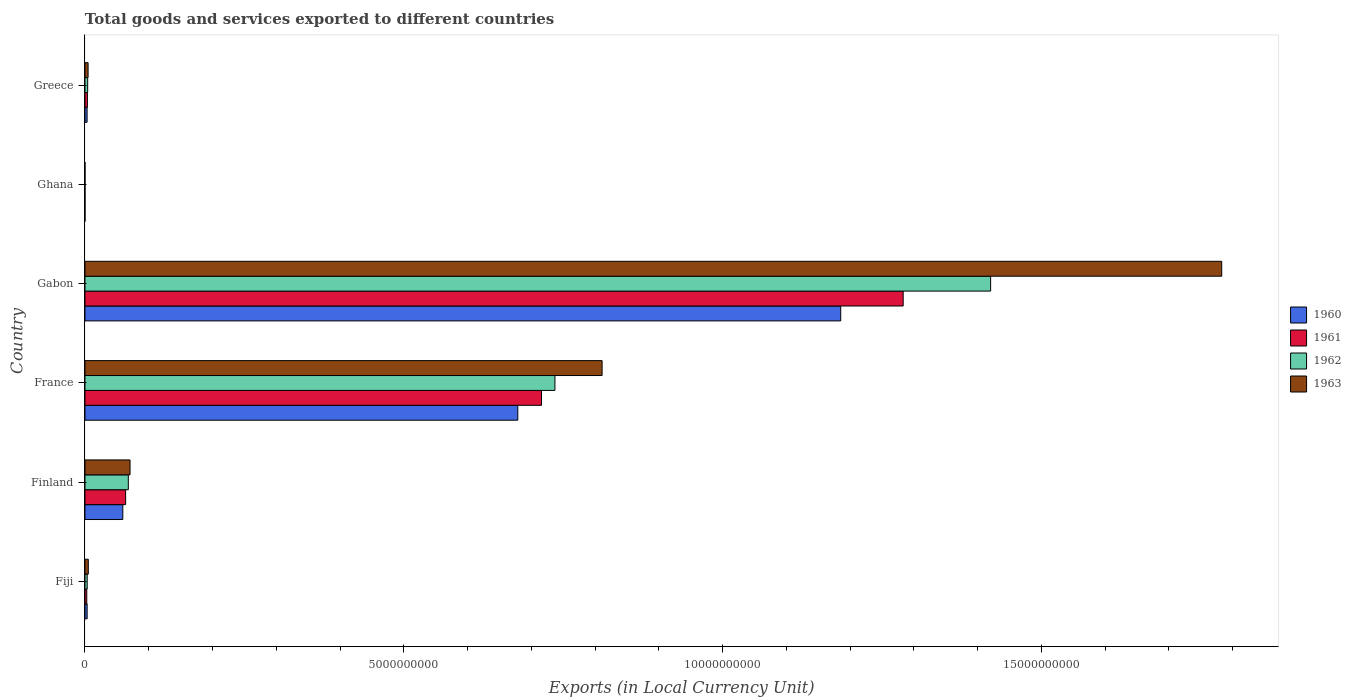How many different coloured bars are there?
Your response must be concise. 4. Are the number of bars on each tick of the Y-axis equal?
Make the answer very short. Yes. How many bars are there on the 5th tick from the top?
Ensure brevity in your answer.  4. How many bars are there on the 2nd tick from the bottom?
Keep it short and to the point. 4. What is the label of the 4th group of bars from the top?
Make the answer very short. France. What is the Amount of goods and services exports in 1962 in France?
Offer a very short reply. 7.37e+09. Across all countries, what is the maximum Amount of goods and services exports in 1961?
Make the answer very short. 1.28e+1. Across all countries, what is the minimum Amount of goods and services exports in 1960?
Your answer should be compact. 2.45e+04. In which country was the Amount of goods and services exports in 1961 maximum?
Offer a terse response. Gabon. What is the total Amount of goods and services exports in 1962 in the graph?
Your response must be concise. 2.23e+1. What is the difference between the Amount of goods and services exports in 1960 in France and that in Gabon?
Your answer should be compact. -5.06e+09. What is the difference between the Amount of goods and services exports in 1961 in France and the Amount of goods and services exports in 1962 in Fiji?
Your answer should be compact. 7.13e+09. What is the average Amount of goods and services exports in 1963 per country?
Offer a very short reply. 4.46e+09. What is the difference between the Amount of goods and services exports in 1961 and Amount of goods and services exports in 1962 in Fiji?
Provide a short and direct response. -6.30e+06. In how many countries, is the Amount of goods and services exports in 1960 greater than 8000000000 LCU?
Give a very brief answer. 1. What is the ratio of the Amount of goods and services exports in 1961 in Fiji to that in Ghana?
Offer a very short reply. 1172.84. Is the Amount of goods and services exports in 1963 in Finland less than that in Greece?
Offer a terse response. No. What is the difference between the highest and the second highest Amount of goods and services exports in 1962?
Offer a very short reply. 6.83e+09. What is the difference between the highest and the lowest Amount of goods and services exports in 1960?
Your answer should be compact. 1.19e+1. Is the sum of the Amount of goods and services exports in 1962 in Fiji and Ghana greater than the maximum Amount of goods and services exports in 1960 across all countries?
Offer a terse response. No. Is it the case that in every country, the sum of the Amount of goods and services exports in 1960 and Amount of goods and services exports in 1961 is greater than the sum of Amount of goods and services exports in 1963 and Amount of goods and services exports in 1962?
Your answer should be compact. No. What does the 1st bar from the top in France represents?
Ensure brevity in your answer.  1963. How many countries are there in the graph?
Offer a terse response. 6. How many legend labels are there?
Ensure brevity in your answer.  4. What is the title of the graph?
Provide a succinct answer. Total goods and services exported to different countries. Does "1983" appear as one of the legend labels in the graph?
Offer a very short reply. No. What is the label or title of the X-axis?
Ensure brevity in your answer.  Exports (in Local Currency Unit). What is the label or title of the Y-axis?
Offer a terse response. Country. What is the Exports (in Local Currency Unit) of 1960 in Fiji?
Provide a short and direct response. 3.40e+07. What is the Exports (in Local Currency Unit) of 1961 in Fiji?
Give a very brief answer. 2.85e+07. What is the Exports (in Local Currency Unit) in 1962 in Fiji?
Your answer should be very brief. 3.48e+07. What is the Exports (in Local Currency Unit) in 1963 in Fiji?
Your answer should be very brief. 5.25e+07. What is the Exports (in Local Currency Unit) in 1960 in Finland?
Provide a short and direct response. 5.94e+08. What is the Exports (in Local Currency Unit) in 1961 in Finland?
Your answer should be very brief. 6.38e+08. What is the Exports (in Local Currency Unit) of 1962 in Finland?
Your answer should be compact. 6.80e+08. What is the Exports (in Local Currency Unit) in 1963 in Finland?
Offer a terse response. 7.07e+08. What is the Exports (in Local Currency Unit) in 1960 in France?
Your answer should be very brief. 6.79e+09. What is the Exports (in Local Currency Unit) in 1961 in France?
Keep it short and to the point. 7.16e+09. What is the Exports (in Local Currency Unit) in 1962 in France?
Keep it short and to the point. 7.37e+09. What is the Exports (in Local Currency Unit) of 1963 in France?
Offer a terse response. 8.11e+09. What is the Exports (in Local Currency Unit) of 1960 in Gabon?
Your response must be concise. 1.19e+1. What is the Exports (in Local Currency Unit) in 1961 in Gabon?
Ensure brevity in your answer.  1.28e+1. What is the Exports (in Local Currency Unit) in 1962 in Gabon?
Your answer should be compact. 1.42e+1. What is the Exports (in Local Currency Unit) of 1963 in Gabon?
Offer a very short reply. 1.78e+1. What is the Exports (in Local Currency Unit) of 1960 in Ghana?
Give a very brief answer. 2.45e+04. What is the Exports (in Local Currency Unit) in 1961 in Ghana?
Give a very brief answer. 2.43e+04. What is the Exports (in Local Currency Unit) of 1962 in Ghana?
Offer a very short reply. 2.39e+04. What is the Exports (in Local Currency Unit) in 1963 in Ghana?
Provide a succinct answer. 2.33e+04. What is the Exports (in Local Currency Unit) in 1960 in Greece?
Provide a succinct answer. 3.33e+07. What is the Exports (in Local Currency Unit) in 1961 in Greece?
Provide a short and direct response. 3.82e+07. What is the Exports (in Local Currency Unit) in 1962 in Greece?
Provide a short and direct response. 4.25e+07. What is the Exports (in Local Currency Unit) of 1963 in Greece?
Provide a short and direct response. 4.90e+07. Across all countries, what is the maximum Exports (in Local Currency Unit) in 1960?
Your response must be concise. 1.19e+1. Across all countries, what is the maximum Exports (in Local Currency Unit) in 1961?
Provide a short and direct response. 1.28e+1. Across all countries, what is the maximum Exports (in Local Currency Unit) in 1962?
Provide a short and direct response. 1.42e+1. Across all countries, what is the maximum Exports (in Local Currency Unit) of 1963?
Give a very brief answer. 1.78e+1. Across all countries, what is the minimum Exports (in Local Currency Unit) in 1960?
Make the answer very short. 2.45e+04. Across all countries, what is the minimum Exports (in Local Currency Unit) of 1961?
Offer a very short reply. 2.43e+04. Across all countries, what is the minimum Exports (in Local Currency Unit) of 1962?
Offer a very short reply. 2.39e+04. Across all countries, what is the minimum Exports (in Local Currency Unit) in 1963?
Your response must be concise. 2.33e+04. What is the total Exports (in Local Currency Unit) of 1960 in the graph?
Make the answer very short. 1.93e+1. What is the total Exports (in Local Currency Unit) in 1961 in the graph?
Make the answer very short. 2.07e+1. What is the total Exports (in Local Currency Unit) of 1962 in the graph?
Make the answer very short. 2.23e+1. What is the total Exports (in Local Currency Unit) in 1963 in the graph?
Your answer should be very brief. 2.67e+1. What is the difference between the Exports (in Local Currency Unit) of 1960 in Fiji and that in Finland?
Make the answer very short. -5.60e+08. What is the difference between the Exports (in Local Currency Unit) of 1961 in Fiji and that in Finland?
Your response must be concise. -6.09e+08. What is the difference between the Exports (in Local Currency Unit) of 1962 in Fiji and that in Finland?
Offer a terse response. -6.45e+08. What is the difference between the Exports (in Local Currency Unit) in 1963 in Fiji and that in Finland?
Your response must be concise. -6.54e+08. What is the difference between the Exports (in Local Currency Unit) of 1960 in Fiji and that in France?
Your response must be concise. -6.75e+09. What is the difference between the Exports (in Local Currency Unit) in 1961 in Fiji and that in France?
Your response must be concise. -7.13e+09. What is the difference between the Exports (in Local Currency Unit) of 1962 in Fiji and that in France?
Give a very brief answer. -7.34e+09. What is the difference between the Exports (in Local Currency Unit) in 1963 in Fiji and that in France?
Your answer should be very brief. -8.06e+09. What is the difference between the Exports (in Local Currency Unit) in 1960 in Fiji and that in Gabon?
Give a very brief answer. -1.18e+1. What is the difference between the Exports (in Local Currency Unit) in 1961 in Fiji and that in Gabon?
Keep it short and to the point. -1.28e+1. What is the difference between the Exports (in Local Currency Unit) in 1962 in Fiji and that in Gabon?
Your answer should be compact. -1.42e+1. What is the difference between the Exports (in Local Currency Unit) in 1963 in Fiji and that in Gabon?
Provide a short and direct response. -1.78e+1. What is the difference between the Exports (in Local Currency Unit) in 1960 in Fiji and that in Ghana?
Your answer should be compact. 3.40e+07. What is the difference between the Exports (in Local Currency Unit) in 1961 in Fiji and that in Ghana?
Your response must be concise. 2.85e+07. What is the difference between the Exports (in Local Currency Unit) in 1962 in Fiji and that in Ghana?
Offer a terse response. 3.48e+07. What is the difference between the Exports (in Local Currency Unit) of 1963 in Fiji and that in Ghana?
Your answer should be compact. 5.25e+07. What is the difference between the Exports (in Local Currency Unit) in 1960 in Fiji and that in Greece?
Your answer should be compact. 6.78e+05. What is the difference between the Exports (in Local Currency Unit) in 1961 in Fiji and that in Greece?
Your response must be concise. -9.72e+06. What is the difference between the Exports (in Local Currency Unit) in 1962 in Fiji and that in Greece?
Your answer should be very brief. -7.71e+06. What is the difference between the Exports (in Local Currency Unit) in 1963 in Fiji and that in Greece?
Keep it short and to the point. 3.52e+06. What is the difference between the Exports (in Local Currency Unit) in 1960 in Finland and that in France?
Offer a terse response. -6.19e+09. What is the difference between the Exports (in Local Currency Unit) in 1961 in Finland and that in France?
Offer a very short reply. -6.52e+09. What is the difference between the Exports (in Local Currency Unit) of 1962 in Finland and that in France?
Provide a succinct answer. -6.69e+09. What is the difference between the Exports (in Local Currency Unit) in 1963 in Finland and that in France?
Ensure brevity in your answer.  -7.40e+09. What is the difference between the Exports (in Local Currency Unit) of 1960 in Finland and that in Gabon?
Provide a short and direct response. -1.13e+1. What is the difference between the Exports (in Local Currency Unit) of 1961 in Finland and that in Gabon?
Your answer should be very brief. -1.22e+1. What is the difference between the Exports (in Local Currency Unit) in 1962 in Finland and that in Gabon?
Give a very brief answer. -1.35e+1. What is the difference between the Exports (in Local Currency Unit) in 1963 in Finland and that in Gabon?
Provide a short and direct response. -1.71e+1. What is the difference between the Exports (in Local Currency Unit) of 1960 in Finland and that in Ghana?
Ensure brevity in your answer.  5.94e+08. What is the difference between the Exports (in Local Currency Unit) of 1961 in Finland and that in Ghana?
Your answer should be compact. 6.38e+08. What is the difference between the Exports (in Local Currency Unit) of 1962 in Finland and that in Ghana?
Your answer should be very brief. 6.80e+08. What is the difference between the Exports (in Local Currency Unit) in 1963 in Finland and that in Ghana?
Make the answer very short. 7.07e+08. What is the difference between the Exports (in Local Currency Unit) in 1960 in Finland and that in Greece?
Offer a terse response. 5.60e+08. What is the difference between the Exports (in Local Currency Unit) in 1961 in Finland and that in Greece?
Offer a terse response. 5.99e+08. What is the difference between the Exports (in Local Currency Unit) in 1962 in Finland and that in Greece?
Your answer should be very brief. 6.37e+08. What is the difference between the Exports (in Local Currency Unit) of 1963 in Finland and that in Greece?
Make the answer very short. 6.58e+08. What is the difference between the Exports (in Local Currency Unit) of 1960 in France and that in Gabon?
Offer a very short reply. -5.06e+09. What is the difference between the Exports (in Local Currency Unit) of 1961 in France and that in Gabon?
Your answer should be very brief. -5.67e+09. What is the difference between the Exports (in Local Currency Unit) in 1962 in France and that in Gabon?
Your answer should be very brief. -6.83e+09. What is the difference between the Exports (in Local Currency Unit) in 1963 in France and that in Gabon?
Your answer should be very brief. -9.72e+09. What is the difference between the Exports (in Local Currency Unit) in 1960 in France and that in Ghana?
Give a very brief answer. 6.79e+09. What is the difference between the Exports (in Local Currency Unit) in 1961 in France and that in Ghana?
Your answer should be very brief. 7.16e+09. What is the difference between the Exports (in Local Currency Unit) in 1962 in France and that in Ghana?
Ensure brevity in your answer.  7.37e+09. What is the difference between the Exports (in Local Currency Unit) in 1963 in France and that in Ghana?
Provide a short and direct response. 8.11e+09. What is the difference between the Exports (in Local Currency Unit) in 1960 in France and that in Greece?
Ensure brevity in your answer.  6.76e+09. What is the difference between the Exports (in Local Currency Unit) in 1961 in France and that in Greece?
Your answer should be very brief. 7.12e+09. What is the difference between the Exports (in Local Currency Unit) of 1962 in France and that in Greece?
Your answer should be very brief. 7.33e+09. What is the difference between the Exports (in Local Currency Unit) in 1963 in France and that in Greece?
Provide a short and direct response. 8.06e+09. What is the difference between the Exports (in Local Currency Unit) of 1960 in Gabon and that in Ghana?
Keep it short and to the point. 1.19e+1. What is the difference between the Exports (in Local Currency Unit) in 1961 in Gabon and that in Ghana?
Give a very brief answer. 1.28e+1. What is the difference between the Exports (in Local Currency Unit) in 1962 in Gabon and that in Ghana?
Ensure brevity in your answer.  1.42e+1. What is the difference between the Exports (in Local Currency Unit) in 1963 in Gabon and that in Ghana?
Provide a short and direct response. 1.78e+1. What is the difference between the Exports (in Local Currency Unit) in 1960 in Gabon and that in Greece?
Provide a succinct answer. 1.18e+1. What is the difference between the Exports (in Local Currency Unit) in 1961 in Gabon and that in Greece?
Provide a short and direct response. 1.28e+1. What is the difference between the Exports (in Local Currency Unit) of 1962 in Gabon and that in Greece?
Your response must be concise. 1.42e+1. What is the difference between the Exports (in Local Currency Unit) in 1963 in Gabon and that in Greece?
Provide a succinct answer. 1.78e+1. What is the difference between the Exports (in Local Currency Unit) in 1960 in Ghana and that in Greece?
Make the answer very short. -3.33e+07. What is the difference between the Exports (in Local Currency Unit) in 1961 in Ghana and that in Greece?
Keep it short and to the point. -3.82e+07. What is the difference between the Exports (in Local Currency Unit) of 1962 in Ghana and that in Greece?
Provide a succinct answer. -4.25e+07. What is the difference between the Exports (in Local Currency Unit) of 1963 in Ghana and that in Greece?
Make the answer very short. -4.90e+07. What is the difference between the Exports (in Local Currency Unit) of 1960 in Fiji and the Exports (in Local Currency Unit) of 1961 in Finland?
Your answer should be very brief. -6.04e+08. What is the difference between the Exports (in Local Currency Unit) in 1960 in Fiji and the Exports (in Local Currency Unit) in 1962 in Finland?
Your response must be concise. -6.46e+08. What is the difference between the Exports (in Local Currency Unit) in 1960 in Fiji and the Exports (in Local Currency Unit) in 1963 in Finland?
Offer a very short reply. -6.73e+08. What is the difference between the Exports (in Local Currency Unit) in 1961 in Fiji and the Exports (in Local Currency Unit) in 1962 in Finland?
Make the answer very short. -6.51e+08. What is the difference between the Exports (in Local Currency Unit) of 1961 in Fiji and the Exports (in Local Currency Unit) of 1963 in Finland?
Provide a short and direct response. -6.78e+08. What is the difference between the Exports (in Local Currency Unit) of 1962 in Fiji and the Exports (in Local Currency Unit) of 1963 in Finland?
Make the answer very short. -6.72e+08. What is the difference between the Exports (in Local Currency Unit) in 1960 in Fiji and the Exports (in Local Currency Unit) in 1961 in France?
Ensure brevity in your answer.  -7.13e+09. What is the difference between the Exports (in Local Currency Unit) in 1960 in Fiji and the Exports (in Local Currency Unit) in 1962 in France?
Give a very brief answer. -7.34e+09. What is the difference between the Exports (in Local Currency Unit) of 1960 in Fiji and the Exports (in Local Currency Unit) of 1963 in France?
Offer a very short reply. -8.08e+09. What is the difference between the Exports (in Local Currency Unit) in 1961 in Fiji and the Exports (in Local Currency Unit) in 1962 in France?
Your answer should be very brief. -7.34e+09. What is the difference between the Exports (in Local Currency Unit) of 1961 in Fiji and the Exports (in Local Currency Unit) of 1963 in France?
Offer a terse response. -8.08e+09. What is the difference between the Exports (in Local Currency Unit) in 1962 in Fiji and the Exports (in Local Currency Unit) in 1963 in France?
Your answer should be compact. -8.08e+09. What is the difference between the Exports (in Local Currency Unit) in 1960 in Fiji and the Exports (in Local Currency Unit) in 1961 in Gabon?
Your response must be concise. -1.28e+1. What is the difference between the Exports (in Local Currency Unit) in 1960 in Fiji and the Exports (in Local Currency Unit) in 1962 in Gabon?
Your answer should be very brief. -1.42e+1. What is the difference between the Exports (in Local Currency Unit) in 1960 in Fiji and the Exports (in Local Currency Unit) in 1963 in Gabon?
Provide a short and direct response. -1.78e+1. What is the difference between the Exports (in Local Currency Unit) of 1961 in Fiji and the Exports (in Local Currency Unit) of 1962 in Gabon?
Make the answer very short. -1.42e+1. What is the difference between the Exports (in Local Currency Unit) in 1961 in Fiji and the Exports (in Local Currency Unit) in 1963 in Gabon?
Your answer should be compact. -1.78e+1. What is the difference between the Exports (in Local Currency Unit) of 1962 in Fiji and the Exports (in Local Currency Unit) of 1963 in Gabon?
Your answer should be compact. -1.78e+1. What is the difference between the Exports (in Local Currency Unit) of 1960 in Fiji and the Exports (in Local Currency Unit) of 1961 in Ghana?
Give a very brief answer. 3.40e+07. What is the difference between the Exports (in Local Currency Unit) in 1960 in Fiji and the Exports (in Local Currency Unit) in 1962 in Ghana?
Your answer should be very brief. 3.40e+07. What is the difference between the Exports (in Local Currency Unit) in 1960 in Fiji and the Exports (in Local Currency Unit) in 1963 in Ghana?
Provide a succinct answer. 3.40e+07. What is the difference between the Exports (in Local Currency Unit) in 1961 in Fiji and the Exports (in Local Currency Unit) in 1962 in Ghana?
Your answer should be compact. 2.85e+07. What is the difference between the Exports (in Local Currency Unit) of 1961 in Fiji and the Exports (in Local Currency Unit) of 1963 in Ghana?
Give a very brief answer. 2.85e+07. What is the difference between the Exports (in Local Currency Unit) of 1962 in Fiji and the Exports (in Local Currency Unit) of 1963 in Ghana?
Give a very brief answer. 3.48e+07. What is the difference between the Exports (in Local Currency Unit) in 1960 in Fiji and the Exports (in Local Currency Unit) in 1961 in Greece?
Keep it short and to the point. -4.22e+06. What is the difference between the Exports (in Local Currency Unit) in 1960 in Fiji and the Exports (in Local Currency Unit) in 1962 in Greece?
Offer a terse response. -8.51e+06. What is the difference between the Exports (in Local Currency Unit) of 1960 in Fiji and the Exports (in Local Currency Unit) of 1963 in Greece?
Offer a terse response. -1.50e+07. What is the difference between the Exports (in Local Currency Unit) of 1961 in Fiji and the Exports (in Local Currency Unit) of 1962 in Greece?
Make the answer very short. -1.40e+07. What is the difference between the Exports (in Local Currency Unit) of 1961 in Fiji and the Exports (in Local Currency Unit) of 1963 in Greece?
Make the answer very short. -2.05e+07. What is the difference between the Exports (in Local Currency Unit) in 1962 in Fiji and the Exports (in Local Currency Unit) in 1963 in Greece?
Offer a very short reply. -1.42e+07. What is the difference between the Exports (in Local Currency Unit) in 1960 in Finland and the Exports (in Local Currency Unit) in 1961 in France?
Give a very brief answer. -6.57e+09. What is the difference between the Exports (in Local Currency Unit) of 1960 in Finland and the Exports (in Local Currency Unit) of 1962 in France?
Your response must be concise. -6.78e+09. What is the difference between the Exports (in Local Currency Unit) in 1960 in Finland and the Exports (in Local Currency Unit) in 1963 in France?
Provide a succinct answer. -7.52e+09. What is the difference between the Exports (in Local Currency Unit) in 1961 in Finland and the Exports (in Local Currency Unit) in 1962 in France?
Make the answer very short. -6.73e+09. What is the difference between the Exports (in Local Currency Unit) of 1961 in Finland and the Exports (in Local Currency Unit) of 1963 in France?
Provide a succinct answer. -7.47e+09. What is the difference between the Exports (in Local Currency Unit) in 1962 in Finland and the Exports (in Local Currency Unit) in 1963 in France?
Offer a terse response. -7.43e+09. What is the difference between the Exports (in Local Currency Unit) in 1960 in Finland and the Exports (in Local Currency Unit) in 1961 in Gabon?
Provide a succinct answer. -1.22e+1. What is the difference between the Exports (in Local Currency Unit) of 1960 in Finland and the Exports (in Local Currency Unit) of 1962 in Gabon?
Your response must be concise. -1.36e+1. What is the difference between the Exports (in Local Currency Unit) in 1960 in Finland and the Exports (in Local Currency Unit) in 1963 in Gabon?
Provide a succinct answer. -1.72e+1. What is the difference between the Exports (in Local Currency Unit) in 1961 in Finland and the Exports (in Local Currency Unit) in 1962 in Gabon?
Your answer should be compact. -1.36e+1. What is the difference between the Exports (in Local Currency Unit) of 1961 in Finland and the Exports (in Local Currency Unit) of 1963 in Gabon?
Your answer should be very brief. -1.72e+1. What is the difference between the Exports (in Local Currency Unit) of 1962 in Finland and the Exports (in Local Currency Unit) of 1963 in Gabon?
Your answer should be compact. -1.71e+1. What is the difference between the Exports (in Local Currency Unit) in 1960 in Finland and the Exports (in Local Currency Unit) in 1961 in Ghana?
Ensure brevity in your answer.  5.94e+08. What is the difference between the Exports (in Local Currency Unit) of 1960 in Finland and the Exports (in Local Currency Unit) of 1962 in Ghana?
Make the answer very short. 5.94e+08. What is the difference between the Exports (in Local Currency Unit) of 1960 in Finland and the Exports (in Local Currency Unit) of 1963 in Ghana?
Your response must be concise. 5.94e+08. What is the difference between the Exports (in Local Currency Unit) in 1961 in Finland and the Exports (in Local Currency Unit) in 1962 in Ghana?
Your response must be concise. 6.38e+08. What is the difference between the Exports (in Local Currency Unit) of 1961 in Finland and the Exports (in Local Currency Unit) of 1963 in Ghana?
Offer a very short reply. 6.38e+08. What is the difference between the Exports (in Local Currency Unit) of 1962 in Finland and the Exports (in Local Currency Unit) of 1963 in Ghana?
Your answer should be compact. 6.80e+08. What is the difference between the Exports (in Local Currency Unit) of 1960 in Finland and the Exports (in Local Currency Unit) of 1961 in Greece?
Provide a succinct answer. 5.55e+08. What is the difference between the Exports (in Local Currency Unit) of 1960 in Finland and the Exports (in Local Currency Unit) of 1962 in Greece?
Your answer should be compact. 5.51e+08. What is the difference between the Exports (in Local Currency Unit) in 1960 in Finland and the Exports (in Local Currency Unit) in 1963 in Greece?
Offer a very short reply. 5.45e+08. What is the difference between the Exports (in Local Currency Unit) of 1961 in Finland and the Exports (in Local Currency Unit) of 1962 in Greece?
Your answer should be very brief. 5.95e+08. What is the difference between the Exports (in Local Currency Unit) of 1961 in Finland and the Exports (in Local Currency Unit) of 1963 in Greece?
Keep it short and to the point. 5.89e+08. What is the difference between the Exports (in Local Currency Unit) in 1962 in Finland and the Exports (in Local Currency Unit) in 1963 in Greece?
Make the answer very short. 6.31e+08. What is the difference between the Exports (in Local Currency Unit) of 1960 in France and the Exports (in Local Currency Unit) of 1961 in Gabon?
Offer a very short reply. -6.04e+09. What is the difference between the Exports (in Local Currency Unit) of 1960 in France and the Exports (in Local Currency Unit) of 1962 in Gabon?
Provide a short and direct response. -7.42e+09. What is the difference between the Exports (in Local Currency Unit) in 1960 in France and the Exports (in Local Currency Unit) in 1963 in Gabon?
Your response must be concise. -1.10e+1. What is the difference between the Exports (in Local Currency Unit) in 1961 in France and the Exports (in Local Currency Unit) in 1962 in Gabon?
Offer a very short reply. -7.04e+09. What is the difference between the Exports (in Local Currency Unit) of 1961 in France and the Exports (in Local Currency Unit) of 1963 in Gabon?
Your response must be concise. -1.07e+1. What is the difference between the Exports (in Local Currency Unit) in 1962 in France and the Exports (in Local Currency Unit) in 1963 in Gabon?
Give a very brief answer. -1.05e+1. What is the difference between the Exports (in Local Currency Unit) of 1960 in France and the Exports (in Local Currency Unit) of 1961 in Ghana?
Give a very brief answer. 6.79e+09. What is the difference between the Exports (in Local Currency Unit) in 1960 in France and the Exports (in Local Currency Unit) in 1962 in Ghana?
Keep it short and to the point. 6.79e+09. What is the difference between the Exports (in Local Currency Unit) of 1960 in France and the Exports (in Local Currency Unit) of 1963 in Ghana?
Provide a succinct answer. 6.79e+09. What is the difference between the Exports (in Local Currency Unit) of 1961 in France and the Exports (in Local Currency Unit) of 1962 in Ghana?
Your response must be concise. 7.16e+09. What is the difference between the Exports (in Local Currency Unit) of 1961 in France and the Exports (in Local Currency Unit) of 1963 in Ghana?
Provide a short and direct response. 7.16e+09. What is the difference between the Exports (in Local Currency Unit) in 1962 in France and the Exports (in Local Currency Unit) in 1963 in Ghana?
Provide a succinct answer. 7.37e+09. What is the difference between the Exports (in Local Currency Unit) of 1960 in France and the Exports (in Local Currency Unit) of 1961 in Greece?
Offer a terse response. 6.75e+09. What is the difference between the Exports (in Local Currency Unit) of 1960 in France and the Exports (in Local Currency Unit) of 1962 in Greece?
Give a very brief answer. 6.75e+09. What is the difference between the Exports (in Local Currency Unit) of 1960 in France and the Exports (in Local Currency Unit) of 1963 in Greece?
Offer a very short reply. 6.74e+09. What is the difference between the Exports (in Local Currency Unit) of 1961 in France and the Exports (in Local Currency Unit) of 1962 in Greece?
Your response must be concise. 7.12e+09. What is the difference between the Exports (in Local Currency Unit) in 1961 in France and the Exports (in Local Currency Unit) in 1963 in Greece?
Give a very brief answer. 7.11e+09. What is the difference between the Exports (in Local Currency Unit) of 1962 in France and the Exports (in Local Currency Unit) of 1963 in Greece?
Offer a terse response. 7.32e+09. What is the difference between the Exports (in Local Currency Unit) of 1960 in Gabon and the Exports (in Local Currency Unit) of 1961 in Ghana?
Offer a very short reply. 1.19e+1. What is the difference between the Exports (in Local Currency Unit) in 1960 in Gabon and the Exports (in Local Currency Unit) in 1962 in Ghana?
Provide a short and direct response. 1.19e+1. What is the difference between the Exports (in Local Currency Unit) in 1960 in Gabon and the Exports (in Local Currency Unit) in 1963 in Ghana?
Offer a terse response. 1.19e+1. What is the difference between the Exports (in Local Currency Unit) in 1961 in Gabon and the Exports (in Local Currency Unit) in 1962 in Ghana?
Provide a short and direct response. 1.28e+1. What is the difference between the Exports (in Local Currency Unit) of 1961 in Gabon and the Exports (in Local Currency Unit) of 1963 in Ghana?
Make the answer very short. 1.28e+1. What is the difference between the Exports (in Local Currency Unit) of 1962 in Gabon and the Exports (in Local Currency Unit) of 1963 in Ghana?
Offer a very short reply. 1.42e+1. What is the difference between the Exports (in Local Currency Unit) in 1960 in Gabon and the Exports (in Local Currency Unit) in 1961 in Greece?
Offer a very short reply. 1.18e+1. What is the difference between the Exports (in Local Currency Unit) in 1960 in Gabon and the Exports (in Local Currency Unit) in 1962 in Greece?
Your response must be concise. 1.18e+1. What is the difference between the Exports (in Local Currency Unit) of 1960 in Gabon and the Exports (in Local Currency Unit) of 1963 in Greece?
Keep it short and to the point. 1.18e+1. What is the difference between the Exports (in Local Currency Unit) of 1961 in Gabon and the Exports (in Local Currency Unit) of 1962 in Greece?
Provide a succinct answer. 1.28e+1. What is the difference between the Exports (in Local Currency Unit) of 1961 in Gabon and the Exports (in Local Currency Unit) of 1963 in Greece?
Your answer should be very brief. 1.28e+1. What is the difference between the Exports (in Local Currency Unit) of 1962 in Gabon and the Exports (in Local Currency Unit) of 1963 in Greece?
Give a very brief answer. 1.42e+1. What is the difference between the Exports (in Local Currency Unit) of 1960 in Ghana and the Exports (in Local Currency Unit) of 1961 in Greece?
Your answer should be compact. -3.82e+07. What is the difference between the Exports (in Local Currency Unit) of 1960 in Ghana and the Exports (in Local Currency Unit) of 1962 in Greece?
Your response must be concise. -4.25e+07. What is the difference between the Exports (in Local Currency Unit) in 1960 in Ghana and the Exports (in Local Currency Unit) in 1963 in Greece?
Your answer should be compact. -4.90e+07. What is the difference between the Exports (in Local Currency Unit) of 1961 in Ghana and the Exports (in Local Currency Unit) of 1962 in Greece?
Give a very brief answer. -4.25e+07. What is the difference between the Exports (in Local Currency Unit) of 1961 in Ghana and the Exports (in Local Currency Unit) of 1963 in Greece?
Your response must be concise. -4.90e+07. What is the difference between the Exports (in Local Currency Unit) in 1962 in Ghana and the Exports (in Local Currency Unit) in 1963 in Greece?
Make the answer very short. -4.90e+07. What is the average Exports (in Local Currency Unit) in 1960 per country?
Your response must be concise. 3.22e+09. What is the average Exports (in Local Currency Unit) of 1961 per country?
Your response must be concise. 3.45e+09. What is the average Exports (in Local Currency Unit) of 1962 per country?
Offer a terse response. 3.72e+09. What is the average Exports (in Local Currency Unit) of 1963 per country?
Give a very brief answer. 4.46e+09. What is the difference between the Exports (in Local Currency Unit) of 1960 and Exports (in Local Currency Unit) of 1961 in Fiji?
Your response must be concise. 5.50e+06. What is the difference between the Exports (in Local Currency Unit) of 1960 and Exports (in Local Currency Unit) of 1962 in Fiji?
Provide a succinct answer. -8.00e+05. What is the difference between the Exports (in Local Currency Unit) in 1960 and Exports (in Local Currency Unit) in 1963 in Fiji?
Provide a short and direct response. -1.85e+07. What is the difference between the Exports (in Local Currency Unit) in 1961 and Exports (in Local Currency Unit) in 1962 in Fiji?
Make the answer very short. -6.30e+06. What is the difference between the Exports (in Local Currency Unit) in 1961 and Exports (in Local Currency Unit) in 1963 in Fiji?
Offer a terse response. -2.40e+07. What is the difference between the Exports (in Local Currency Unit) of 1962 and Exports (in Local Currency Unit) of 1963 in Fiji?
Your answer should be compact. -1.77e+07. What is the difference between the Exports (in Local Currency Unit) of 1960 and Exports (in Local Currency Unit) of 1961 in Finland?
Offer a terse response. -4.42e+07. What is the difference between the Exports (in Local Currency Unit) of 1960 and Exports (in Local Currency Unit) of 1962 in Finland?
Ensure brevity in your answer.  -8.63e+07. What is the difference between the Exports (in Local Currency Unit) of 1960 and Exports (in Local Currency Unit) of 1963 in Finland?
Your answer should be compact. -1.13e+08. What is the difference between the Exports (in Local Currency Unit) in 1961 and Exports (in Local Currency Unit) in 1962 in Finland?
Your answer should be very brief. -4.21e+07. What is the difference between the Exports (in Local Currency Unit) in 1961 and Exports (in Local Currency Unit) in 1963 in Finland?
Ensure brevity in your answer.  -6.91e+07. What is the difference between the Exports (in Local Currency Unit) of 1962 and Exports (in Local Currency Unit) of 1963 in Finland?
Offer a very short reply. -2.71e+07. What is the difference between the Exports (in Local Currency Unit) in 1960 and Exports (in Local Currency Unit) in 1961 in France?
Your response must be concise. -3.72e+08. What is the difference between the Exports (in Local Currency Unit) of 1960 and Exports (in Local Currency Unit) of 1962 in France?
Provide a succinct answer. -5.82e+08. What is the difference between the Exports (in Local Currency Unit) of 1960 and Exports (in Local Currency Unit) of 1963 in France?
Your answer should be compact. -1.32e+09. What is the difference between the Exports (in Local Currency Unit) in 1961 and Exports (in Local Currency Unit) in 1962 in France?
Keep it short and to the point. -2.11e+08. What is the difference between the Exports (in Local Currency Unit) of 1961 and Exports (in Local Currency Unit) of 1963 in France?
Your response must be concise. -9.50e+08. What is the difference between the Exports (in Local Currency Unit) in 1962 and Exports (in Local Currency Unit) in 1963 in France?
Offer a terse response. -7.39e+08. What is the difference between the Exports (in Local Currency Unit) of 1960 and Exports (in Local Currency Unit) of 1961 in Gabon?
Ensure brevity in your answer.  -9.80e+08. What is the difference between the Exports (in Local Currency Unit) of 1960 and Exports (in Local Currency Unit) of 1962 in Gabon?
Offer a very short reply. -2.35e+09. What is the difference between the Exports (in Local Currency Unit) in 1960 and Exports (in Local Currency Unit) in 1963 in Gabon?
Offer a terse response. -5.98e+09. What is the difference between the Exports (in Local Currency Unit) in 1961 and Exports (in Local Currency Unit) in 1962 in Gabon?
Give a very brief answer. -1.37e+09. What is the difference between the Exports (in Local Currency Unit) in 1961 and Exports (in Local Currency Unit) in 1963 in Gabon?
Your response must be concise. -5.00e+09. What is the difference between the Exports (in Local Currency Unit) of 1962 and Exports (in Local Currency Unit) of 1963 in Gabon?
Your answer should be very brief. -3.62e+09. What is the difference between the Exports (in Local Currency Unit) in 1960 and Exports (in Local Currency Unit) in 1961 in Ghana?
Your answer should be compact. 200. What is the difference between the Exports (in Local Currency Unit) of 1960 and Exports (in Local Currency Unit) of 1962 in Ghana?
Your response must be concise. 600. What is the difference between the Exports (in Local Currency Unit) of 1960 and Exports (in Local Currency Unit) of 1963 in Ghana?
Your answer should be very brief. 1200. What is the difference between the Exports (in Local Currency Unit) of 1962 and Exports (in Local Currency Unit) of 1963 in Ghana?
Make the answer very short. 600. What is the difference between the Exports (in Local Currency Unit) of 1960 and Exports (in Local Currency Unit) of 1961 in Greece?
Offer a terse response. -4.90e+06. What is the difference between the Exports (in Local Currency Unit) of 1960 and Exports (in Local Currency Unit) of 1962 in Greece?
Provide a short and direct response. -9.19e+06. What is the difference between the Exports (in Local Currency Unit) in 1960 and Exports (in Local Currency Unit) in 1963 in Greece?
Your response must be concise. -1.57e+07. What is the difference between the Exports (in Local Currency Unit) of 1961 and Exports (in Local Currency Unit) of 1962 in Greece?
Your response must be concise. -4.29e+06. What is the difference between the Exports (in Local Currency Unit) in 1961 and Exports (in Local Currency Unit) in 1963 in Greece?
Your response must be concise. -1.08e+07. What is the difference between the Exports (in Local Currency Unit) of 1962 and Exports (in Local Currency Unit) of 1963 in Greece?
Give a very brief answer. -6.47e+06. What is the ratio of the Exports (in Local Currency Unit) of 1960 in Fiji to that in Finland?
Ensure brevity in your answer.  0.06. What is the ratio of the Exports (in Local Currency Unit) in 1961 in Fiji to that in Finland?
Your answer should be compact. 0.04. What is the ratio of the Exports (in Local Currency Unit) of 1962 in Fiji to that in Finland?
Offer a terse response. 0.05. What is the ratio of the Exports (in Local Currency Unit) in 1963 in Fiji to that in Finland?
Keep it short and to the point. 0.07. What is the ratio of the Exports (in Local Currency Unit) in 1960 in Fiji to that in France?
Your response must be concise. 0.01. What is the ratio of the Exports (in Local Currency Unit) in 1961 in Fiji to that in France?
Make the answer very short. 0. What is the ratio of the Exports (in Local Currency Unit) in 1962 in Fiji to that in France?
Keep it short and to the point. 0. What is the ratio of the Exports (in Local Currency Unit) of 1963 in Fiji to that in France?
Your response must be concise. 0.01. What is the ratio of the Exports (in Local Currency Unit) of 1960 in Fiji to that in Gabon?
Make the answer very short. 0. What is the ratio of the Exports (in Local Currency Unit) of 1961 in Fiji to that in Gabon?
Ensure brevity in your answer.  0. What is the ratio of the Exports (in Local Currency Unit) of 1962 in Fiji to that in Gabon?
Keep it short and to the point. 0. What is the ratio of the Exports (in Local Currency Unit) of 1963 in Fiji to that in Gabon?
Offer a terse response. 0. What is the ratio of the Exports (in Local Currency Unit) of 1960 in Fiji to that in Ghana?
Keep it short and to the point. 1387.76. What is the ratio of the Exports (in Local Currency Unit) of 1961 in Fiji to that in Ghana?
Offer a very short reply. 1172.84. What is the ratio of the Exports (in Local Currency Unit) of 1962 in Fiji to that in Ghana?
Ensure brevity in your answer.  1456.07. What is the ratio of the Exports (in Local Currency Unit) of 1963 in Fiji to that in Ghana?
Ensure brevity in your answer.  2253.22. What is the ratio of the Exports (in Local Currency Unit) in 1960 in Fiji to that in Greece?
Ensure brevity in your answer.  1.02. What is the ratio of the Exports (in Local Currency Unit) of 1961 in Fiji to that in Greece?
Your response must be concise. 0.75. What is the ratio of the Exports (in Local Currency Unit) of 1962 in Fiji to that in Greece?
Your response must be concise. 0.82. What is the ratio of the Exports (in Local Currency Unit) in 1963 in Fiji to that in Greece?
Offer a very short reply. 1.07. What is the ratio of the Exports (in Local Currency Unit) in 1960 in Finland to that in France?
Provide a succinct answer. 0.09. What is the ratio of the Exports (in Local Currency Unit) of 1961 in Finland to that in France?
Your response must be concise. 0.09. What is the ratio of the Exports (in Local Currency Unit) of 1962 in Finland to that in France?
Provide a short and direct response. 0.09. What is the ratio of the Exports (in Local Currency Unit) of 1963 in Finland to that in France?
Give a very brief answer. 0.09. What is the ratio of the Exports (in Local Currency Unit) of 1960 in Finland to that in Gabon?
Offer a very short reply. 0.05. What is the ratio of the Exports (in Local Currency Unit) of 1961 in Finland to that in Gabon?
Ensure brevity in your answer.  0.05. What is the ratio of the Exports (in Local Currency Unit) in 1962 in Finland to that in Gabon?
Provide a succinct answer. 0.05. What is the ratio of the Exports (in Local Currency Unit) in 1963 in Finland to that in Gabon?
Give a very brief answer. 0.04. What is the ratio of the Exports (in Local Currency Unit) of 1960 in Finland to that in Ghana?
Provide a short and direct response. 2.42e+04. What is the ratio of the Exports (in Local Currency Unit) of 1961 in Finland to that in Ghana?
Offer a very short reply. 2.62e+04. What is the ratio of the Exports (in Local Currency Unit) of 1962 in Finland to that in Ghana?
Your answer should be very brief. 2.84e+04. What is the ratio of the Exports (in Local Currency Unit) of 1963 in Finland to that in Ghana?
Your answer should be very brief. 3.03e+04. What is the ratio of the Exports (in Local Currency Unit) in 1960 in Finland to that in Greece?
Offer a very short reply. 17.81. What is the ratio of the Exports (in Local Currency Unit) in 1961 in Finland to that in Greece?
Keep it short and to the point. 16.69. What is the ratio of the Exports (in Local Currency Unit) in 1962 in Finland to that in Greece?
Your answer should be very brief. 15.99. What is the ratio of the Exports (in Local Currency Unit) in 1963 in Finland to that in Greece?
Make the answer very short. 14.43. What is the ratio of the Exports (in Local Currency Unit) in 1960 in France to that in Gabon?
Provide a short and direct response. 0.57. What is the ratio of the Exports (in Local Currency Unit) in 1961 in France to that in Gabon?
Keep it short and to the point. 0.56. What is the ratio of the Exports (in Local Currency Unit) in 1962 in France to that in Gabon?
Your response must be concise. 0.52. What is the ratio of the Exports (in Local Currency Unit) in 1963 in France to that in Gabon?
Offer a very short reply. 0.45. What is the ratio of the Exports (in Local Currency Unit) of 1960 in France to that in Ghana?
Provide a short and direct response. 2.77e+05. What is the ratio of the Exports (in Local Currency Unit) of 1961 in France to that in Ghana?
Make the answer very short. 2.95e+05. What is the ratio of the Exports (in Local Currency Unit) of 1962 in France to that in Ghana?
Provide a short and direct response. 3.08e+05. What is the ratio of the Exports (in Local Currency Unit) of 1963 in France to that in Ghana?
Give a very brief answer. 3.48e+05. What is the ratio of the Exports (in Local Currency Unit) of 1960 in France to that in Greece?
Your answer should be very brief. 203.73. What is the ratio of the Exports (in Local Currency Unit) of 1961 in France to that in Greece?
Ensure brevity in your answer.  187.34. What is the ratio of the Exports (in Local Currency Unit) in 1962 in France to that in Greece?
Offer a terse response. 173.41. What is the ratio of the Exports (in Local Currency Unit) in 1963 in France to that in Greece?
Offer a very short reply. 165.59. What is the ratio of the Exports (in Local Currency Unit) in 1960 in Gabon to that in Ghana?
Offer a terse response. 4.84e+05. What is the ratio of the Exports (in Local Currency Unit) of 1961 in Gabon to that in Ghana?
Make the answer very short. 5.28e+05. What is the ratio of the Exports (in Local Currency Unit) in 1962 in Gabon to that in Ghana?
Your answer should be compact. 5.94e+05. What is the ratio of the Exports (in Local Currency Unit) in 1963 in Gabon to that in Ghana?
Make the answer very short. 7.65e+05. What is the ratio of the Exports (in Local Currency Unit) in 1960 in Gabon to that in Greece?
Provide a short and direct response. 355.72. What is the ratio of the Exports (in Local Currency Unit) of 1961 in Gabon to that in Greece?
Provide a succinct answer. 335.76. What is the ratio of the Exports (in Local Currency Unit) of 1962 in Gabon to that in Greece?
Your answer should be compact. 334.16. What is the ratio of the Exports (in Local Currency Unit) of 1963 in Gabon to that in Greece?
Provide a short and direct response. 364.01. What is the ratio of the Exports (in Local Currency Unit) of 1960 in Ghana to that in Greece?
Offer a very short reply. 0. What is the ratio of the Exports (in Local Currency Unit) in 1961 in Ghana to that in Greece?
Ensure brevity in your answer.  0. What is the ratio of the Exports (in Local Currency Unit) of 1962 in Ghana to that in Greece?
Your response must be concise. 0. What is the difference between the highest and the second highest Exports (in Local Currency Unit) of 1960?
Offer a terse response. 5.06e+09. What is the difference between the highest and the second highest Exports (in Local Currency Unit) of 1961?
Offer a terse response. 5.67e+09. What is the difference between the highest and the second highest Exports (in Local Currency Unit) in 1962?
Give a very brief answer. 6.83e+09. What is the difference between the highest and the second highest Exports (in Local Currency Unit) in 1963?
Offer a terse response. 9.72e+09. What is the difference between the highest and the lowest Exports (in Local Currency Unit) in 1960?
Offer a very short reply. 1.19e+1. What is the difference between the highest and the lowest Exports (in Local Currency Unit) in 1961?
Provide a succinct answer. 1.28e+1. What is the difference between the highest and the lowest Exports (in Local Currency Unit) of 1962?
Keep it short and to the point. 1.42e+1. What is the difference between the highest and the lowest Exports (in Local Currency Unit) in 1963?
Keep it short and to the point. 1.78e+1. 